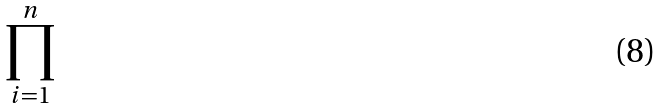<formula> <loc_0><loc_0><loc_500><loc_500>\prod _ { i = 1 } ^ { n }</formula> 